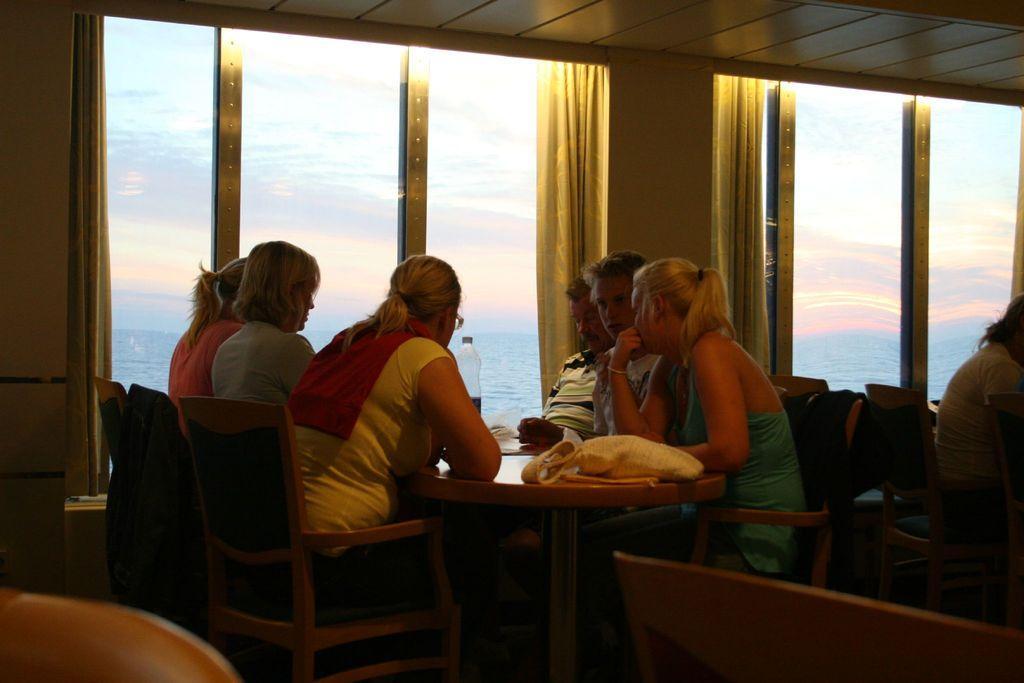Could you give a brief overview of what you see in this image? In this image, group of people are sat on the chairs. The right side, we can see a human is sat on the chair. In the middle, we can see a table. There are few items are placed on it. At the background, we can see glass window, curtains, sky and water. 